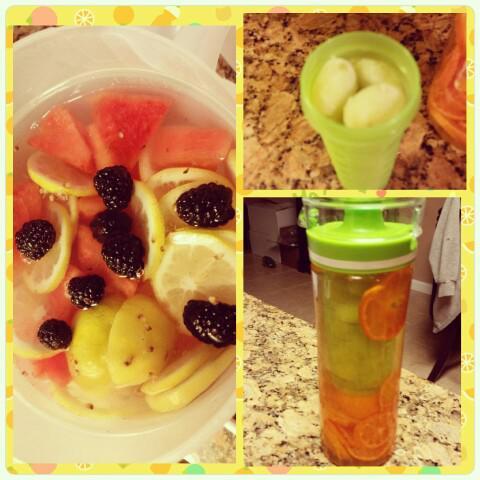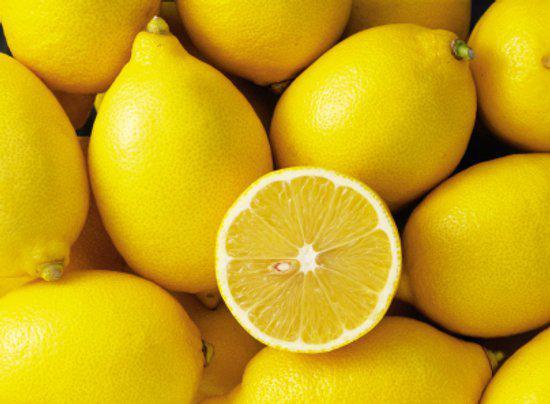The first image is the image on the left, the second image is the image on the right. For the images shown, is this caption "At least one image features a bunch of purple grapes on the vine." true? Answer yes or no. No. 